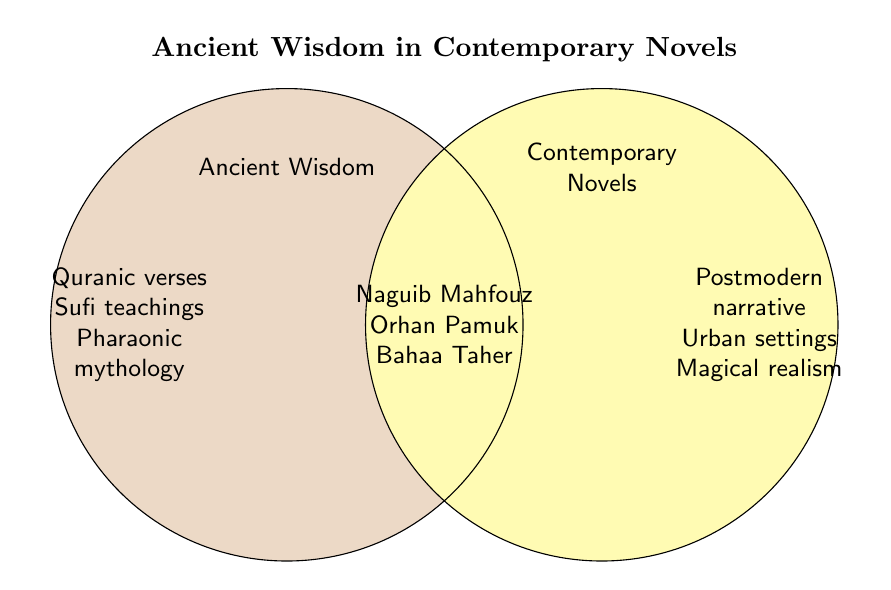What is the title of the figure? Look at the text in bold at the top of the figure. It states the title.
Answer: Ancient Wisdom in Contemporary Novels What does the yellow circle represent? The label inside the yellow circle indicates what it represents.
Answer: Contemporary Novels What literary work appears in both categories? The central overlapping area lists items present in both categories.
Answer: Naguib Mahfouz Between Ancient Wisdom and Contemporary Novels, which category includes "Urban settings"? The text to the far right, outside the central overlap, belongs to Contemporary Novels.
Answer: Contemporary Novels What are the elements located only in the Ancient Wisdom circle? The text in the non-overlapping portion of the Ancient Wisdom circle gives these elements.
Answer: Quranic verses, Sufi teachings, Pharaonic mythology Which author is noted for integrating Sufi teachings and contemporary themes? Find Sufi teachings in the Ancient Wisdom circle and check the overlapping section for authors that integrate these themes with contemporary contexts.
Answer: Orhan Pamuk How many elements are common to both Ancient Wisdom and Contemporary Novels? Count the number of items listed in the central overlapping area.
Answer: Three Compare the number of elements in the Ancient Wisdom circle and the Contemporary Novels circle. Which has more? Count the individual elements listed in each circle and compare.
Answer: Ancient Wisdom Identify an author related to Pharaonic mythology and contemporary themes. Locate Pharaonic mythology in the Ancient Wisdom circle and check the overlapping area for corresponding authors.
Answer: Bahaa Taher 